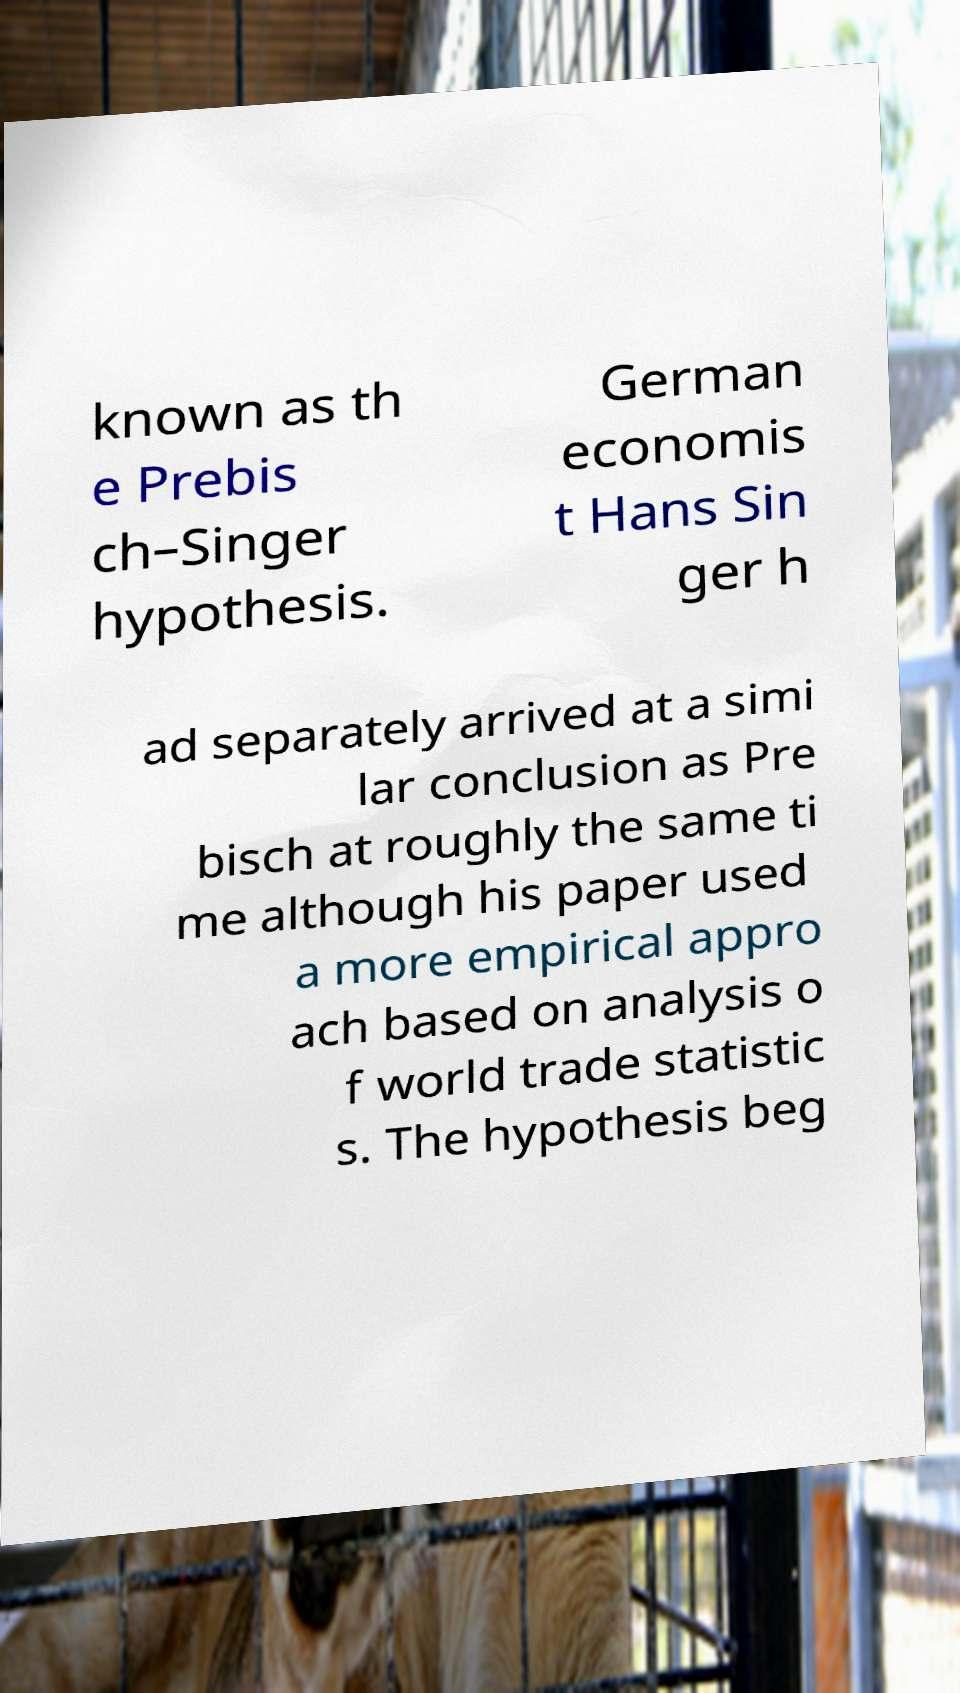Please identify and transcribe the text found in this image. known as th e Prebis ch–Singer hypothesis. German economis t Hans Sin ger h ad separately arrived at a simi lar conclusion as Pre bisch at roughly the same ti me although his paper used a more empirical appro ach based on analysis o f world trade statistic s. The hypothesis beg 